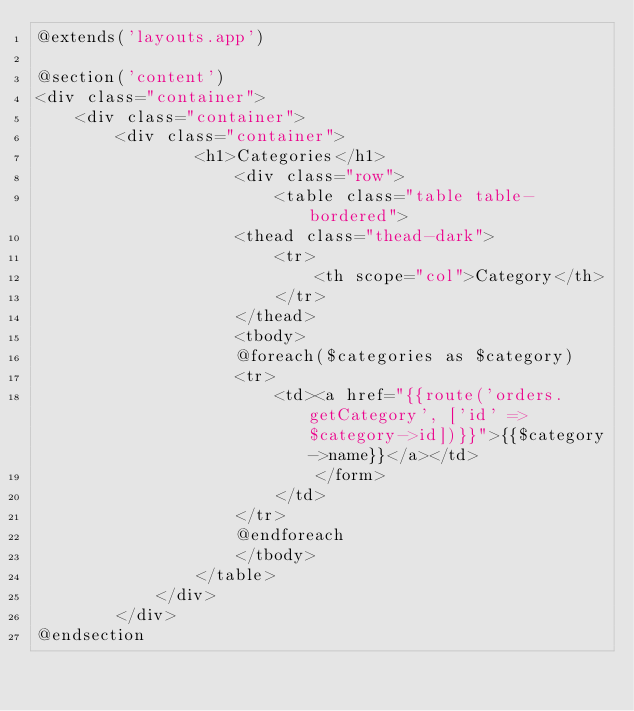<code> <loc_0><loc_0><loc_500><loc_500><_PHP_>@extends('layouts.app')

@section('content')
<div class="container">
    <div class="container">
        <div class="container">
                <h1>Categories</h1>
                    <div class="row">
                        <table class="table table-bordered">        
                    <thead class="thead-dark">
                        <tr>
                            <th scope="col">Category</th>
                        </tr>
                    </thead>
                    <tbody>
                    @foreach($categories as $category)
                    <tr>
                        <td><a href="{{route('orders.getCategory', ['id' => $category->id])}}">{{$category->name}}</a></td>
                            </form>
                        </td>
                    </tr>
                    @endforeach
                    </tbody>
                </table>
            </div>
        </div>
@endsection
</code> 